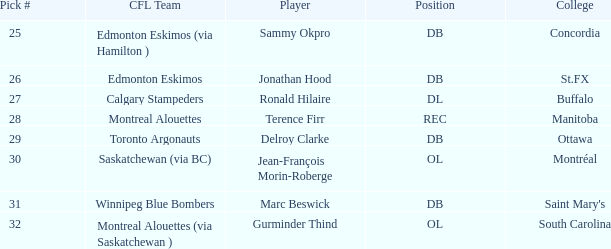Which cfl team has a selection number greater than 31? Montreal Alouettes (via Saskatchewan ). 